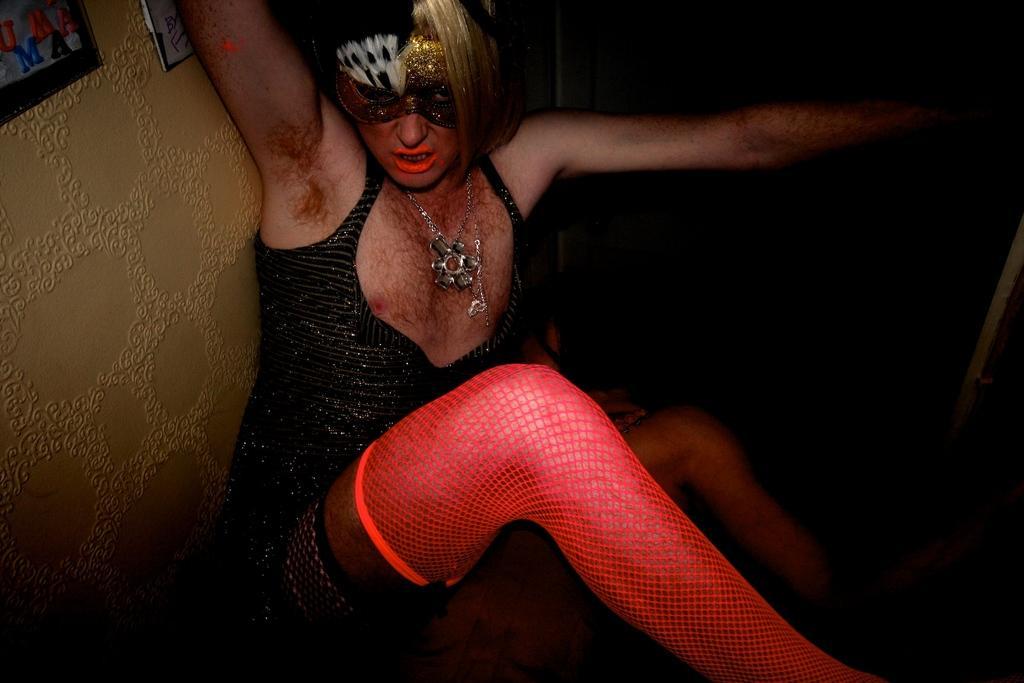In one or two sentences, can you explain what this image depicts? In this image there is a person with black and gold mask. On the left there is a wall and to the wall there are frames attached. 